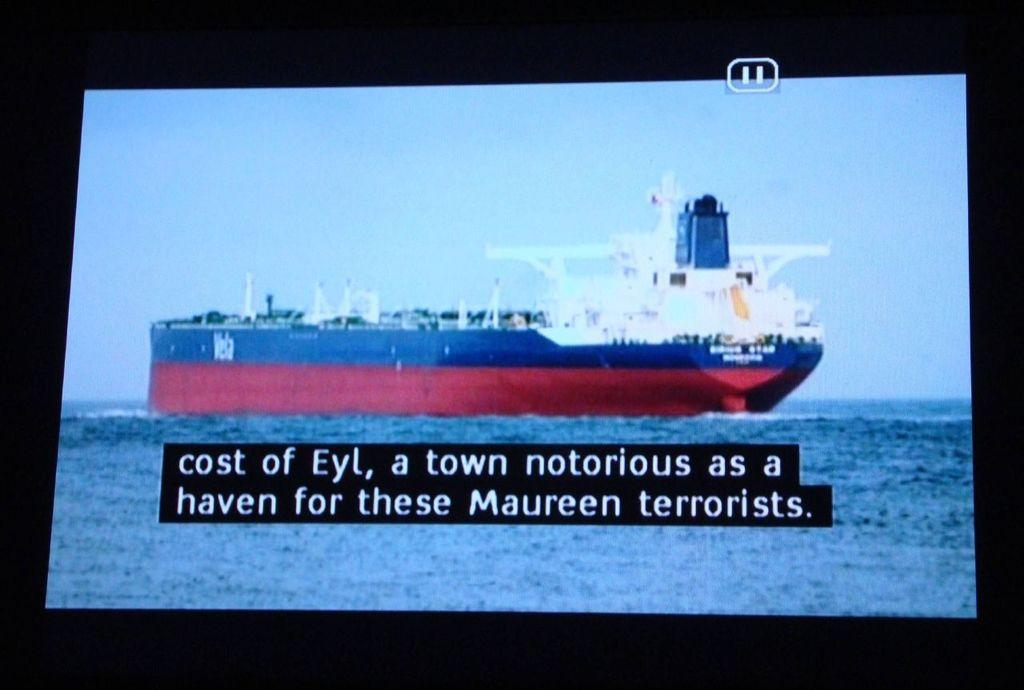<image>
Give a short and clear explanation of the subsequent image. Closed caption screen shot of a large boat with a caption "cost of Eyl, a town notorious as a haven for these Maureen terrorists". 